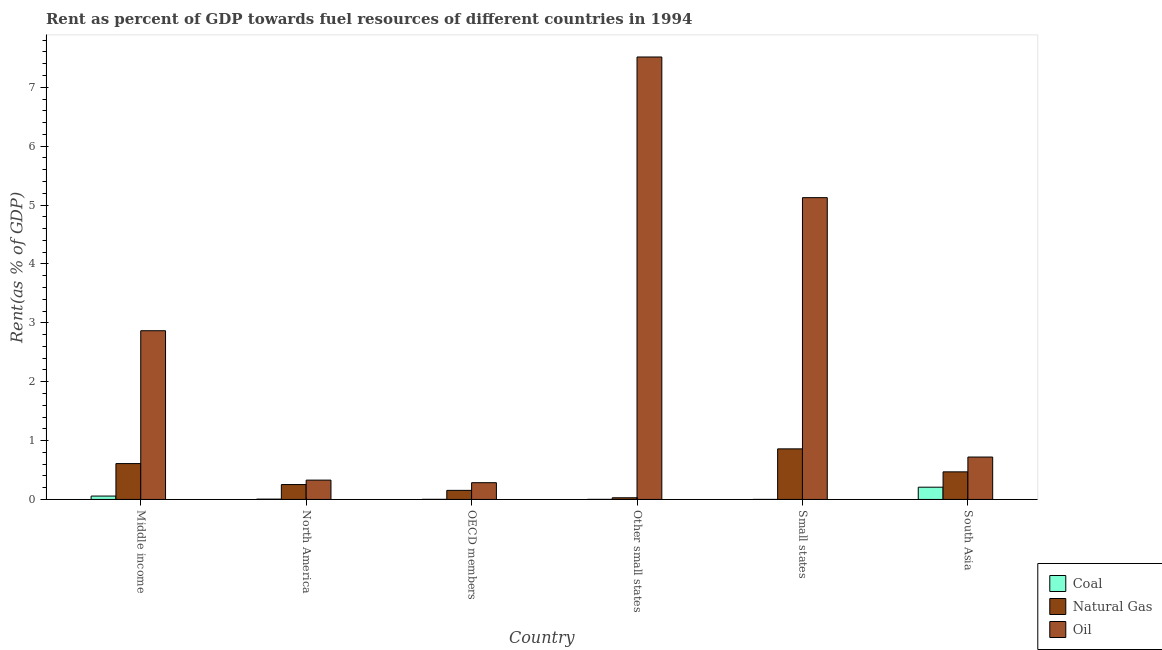How many different coloured bars are there?
Provide a short and direct response. 3. How many groups of bars are there?
Your answer should be compact. 6. Are the number of bars per tick equal to the number of legend labels?
Your response must be concise. Yes. How many bars are there on the 2nd tick from the left?
Your response must be concise. 3. What is the label of the 3rd group of bars from the left?
Provide a short and direct response. OECD members. What is the rent towards coal in Small states?
Keep it short and to the point. 0. Across all countries, what is the maximum rent towards oil?
Your answer should be very brief. 7.51. Across all countries, what is the minimum rent towards natural gas?
Provide a succinct answer. 0.03. In which country was the rent towards coal minimum?
Provide a succinct answer. Small states. What is the total rent towards natural gas in the graph?
Your response must be concise. 2.37. What is the difference between the rent towards coal in Small states and that in South Asia?
Provide a succinct answer. -0.21. What is the difference between the rent towards coal in North America and the rent towards natural gas in Other small states?
Your response must be concise. -0.02. What is the average rent towards natural gas per country?
Ensure brevity in your answer.  0.4. What is the difference between the rent towards natural gas and rent towards coal in OECD members?
Offer a very short reply. 0.15. What is the ratio of the rent towards natural gas in Middle income to that in North America?
Your answer should be very brief. 2.41. Is the rent towards natural gas in Middle income less than that in North America?
Offer a terse response. No. Is the difference between the rent towards oil in Middle income and North America greater than the difference between the rent towards coal in Middle income and North America?
Your answer should be compact. Yes. What is the difference between the highest and the second highest rent towards coal?
Your answer should be very brief. 0.15. What is the difference between the highest and the lowest rent towards natural gas?
Your answer should be compact. 0.83. What does the 3rd bar from the left in Other small states represents?
Offer a very short reply. Oil. What does the 2nd bar from the right in Middle income represents?
Make the answer very short. Natural Gas. How many bars are there?
Keep it short and to the point. 18. Are all the bars in the graph horizontal?
Provide a short and direct response. No. What is the difference between two consecutive major ticks on the Y-axis?
Your response must be concise. 1. Does the graph contain any zero values?
Ensure brevity in your answer.  No. Where does the legend appear in the graph?
Offer a terse response. Bottom right. How many legend labels are there?
Ensure brevity in your answer.  3. What is the title of the graph?
Your response must be concise. Rent as percent of GDP towards fuel resources of different countries in 1994. What is the label or title of the X-axis?
Provide a succinct answer. Country. What is the label or title of the Y-axis?
Provide a short and direct response. Rent(as % of GDP). What is the Rent(as % of GDP) in Coal in Middle income?
Your response must be concise. 0.06. What is the Rent(as % of GDP) in Natural Gas in Middle income?
Your answer should be compact. 0.61. What is the Rent(as % of GDP) of Oil in Middle income?
Keep it short and to the point. 2.87. What is the Rent(as % of GDP) in Coal in North America?
Make the answer very short. 0.01. What is the Rent(as % of GDP) in Natural Gas in North America?
Make the answer very short. 0.25. What is the Rent(as % of GDP) of Oil in North America?
Make the answer very short. 0.33. What is the Rent(as % of GDP) of Coal in OECD members?
Give a very brief answer. 0. What is the Rent(as % of GDP) in Natural Gas in OECD members?
Keep it short and to the point. 0.15. What is the Rent(as % of GDP) in Oil in OECD members?
Provide a succinct answer. 0.28. What is the Rent(as % of GDP) of Coal in Other small states?
Your response must be concise. 0. What is the Rent(as % of GDP) in Natural Gas in Other small states?
Keep it short and to the point. 0.03. What is the Rent(as % of GDP) in Oil in Other small states?
Your response must be concise. 7.51. What is the Rent(as % of GDP) in Coal in Small states?
Your answer should be compact. 0. What is the Rent(as % of GDP) of Natural Gas in Small states?
Make the answer very short. 0.86. What is the Rent(as % of GDP) of Oil in Small states?
Ensure brevity in your answer.  5.13. What is the Rent(as % of GDP) in Coal in South Asia?
Provide a succinct answer. 0.21. What is the Rent(as % of GDP) in Natural Gas in South Asia?
Make the answer very short. 0.47. What is the Rent(as % of GDP) in Oil in South Asia?
Ensure brevity in your answer.  0.72. Across all countries, what is the maximum Rent(as % of GDP) of Coal?
Keep it short and to the point. 0.21. Across all countries, what is the maximum Rent(as % of GDP) in Natural Gas?
Provide a short and direct response. 0.86. Across all countries, what is the maximum Rent(as % of GDP) in Oil?
Keep it short and to the point. 7.51. Across all countries, what is the minimum Rent(as % of GDP) of Coal?
Your answer should be compact. 0. Across all countries, what is the minimum Rent(as % of GDP) in Natural Gas?
Your answer should be compact. 0.03. Across all countries, what is the minimum Rent(as % of GDP) in Oil?
Offer a very short reply. 0.28. What is the total Rent(as % of GDP) of Coal in the graph?
Offer a very short reply. 0.27. What is the total Rent(as % of GDP) of Natural Gas in the graph?
Your answer should be compact. 2.37. What is the total Rent(as % of GDP) in Oil in the graph?
Give a very brief answer. 16.84. What is the difference between the Rent(as % of GDP) of Coal in Middle income and that in North America?
Your response must be concise. 0.05. What is the difference between the Rent(as % of GDP) in Natural Gas in Middle income and that in North America?
Ensure brevity in your answer.  0.36. What is the difference between the Rent(as % of GDP) in Oil in Middle income and that in North America?
Offer a terse response. 2.54. What is the difference between the Rent(as % of GDP) of Coal in Middle income and that in OECD members?
Keep it short and to the point. 0.06. What is the difference between the Rent(as % of GDP) of Natural Gas in Middle income and that in OECD members?
Your answer should be very brief. 0.45. What is the difference between the Rent(as % of GDP) in Oil in Middle income and that in OECD members?
Your response must be concise. 2.58. What is the difference between the Rent(as % of GDP) of Coal in Middle income and that in Other small states?
Ensure brevity in your answer.  0.06. What is the difference between the Rent(as % of GDP) in Natural Gas in Middle income and that in Other small states?
Keep it short and to the point. 0.58. What is the difference between the Rent(as % of GDP) in Oil in Middle income and that in Other small states?
Keep it short and to the point. -4.65. What is the difference between the Rent(as % of GDP) in Coal in Middle income and that in Small states?
Provide a succinct answer. 0.06. What is the difference between the Rent(as % of GDP) in Natural Gas in Middle income and that in Small states?
Make the answer very short. -0.25. What is the difference between the Rent(as % of GDP) in Oil in Middle income and that in Small states?
Keep it short and to the point. -2.26. What is the difference between the Rent(as % of GDP) in Coal in Middle income and that in South Asia?
Make the answer very short. -0.15. What is the difference between the Rent(as % of GDP) in Natural Gas in Middle income and that in South Asia?
Offer a terse response. 0.14. What is the difference between the Rent(as % of GDP) of Oil in Middle income and that in South Asia?
Make the answer very short. 2.15. What is the difference between the Rent(as % of GDP) of Coal in North America and that in OECD members?
Your response must be concise. 0. What is the difference between the Rent(as % of GDP) in Natural Gas in North America and that in OECD members?
Keep it short and to the point. 0.1. What is the difference between the Rent(as % of GDP) in Oil in North America and that in OECD members?
Keep it short and to the point. 0.04. What is the difference between the Rent(as % of GDP) of Coal in North America and that in Other small states?
Provide a succinct answer. 0. What is the difference between the Rent(as % of GDP) in Natural Gas in North America and that in Other small states?
Ensure brevity in your answer.  0.22. What is the difference between the Rent(as % of GDP) of Oil in North America and that in Other small states?
Make the answer very short. -7.19. What is the difference between the Rent(as % of GDP) in Coal in North America and that in Small states?
Give a very brief answer. 0. What is the difference between the Rent(as % of GDP) of Natural Gas in North America and that in Small states?
Offer a very short reply. -0.61. What is the difference between the Rent(as % of GDP) in Oil in North America and that in Small states?
Your answer should be compact. -4.8. What is the difference between the Rent(as % of GDP) of Coal in North America and that in South Asia?
Offer a very short reply. -0.2. What is the difference between the Rent(as % of GDP) of Natural Gas in North America and that in South Asia?
Ensure brevity in your answer.  -0.22. What is the difference between the Rent(as % of GDP) in Oil in North America and that in South Asia?
Your response must be concise. -0.39. What is the difference between the Rent(as % of GDP) in Coal in OECD members and that in Other small states?
Offer a terse response. 0. What is the difference between the Rent(as % of GDP) in Natural Gas in OECD members and that in Other small states?
Keep it short and to the point. 0.13. What is the difference between the Rent(as % of GDP) in Oil in OECD members and that in Other small states?
Provide a succinct answer. -7.23. What is the difference between the Rent(as % of GDP) of Coal in OECD members and that in Small states?
Provide a succinct answer. 0. What is the difference between the Rent(as % of GDP) of Natural Gas in OECD members and that in Small states?
Your answer should be very brief. -0.7. What is the difference between the Rent(as % of GDP) in Oil in OECD members and that in Small states?
Your answer should be very brief. -4.84. What is the difference between the Rent(as % of GDP) of Coal in OECD members and that in South Asia?
Give a very brief answer. -0.21. What is the difference between the Rent(as % of GDP) in Natural Gas in OECD members and that in South Asia?
Offer a terse response. -0.31. What is the difference between the Rent(as % of GDP) in Oil in OECD members and that in South Asia?
Offer a terse response. -0.44. What is the difference between the Rent(as % of GDP) of Coal in Other small states and that in Small states?
Provide a short and direct response. 0. What is the difference between the Rent(as % of GDP) of Natural Gas in Other small states and that in Small states?
Offer a terse response. -0.83. What is the difference between the Rent(as % of GDP) of Oil in Other small states and that in Small states?
Your response must be concise. 2.39. What is the difference between the Rent(as % of GDP) of Coal in Other small states and that in South Asia?
Your answer should be compact. -0.21. What is the difference between the Rent(as % of GDP) in Natural Gas in Other small states and that in South Asia?
Give a very brief answer. -0.44. What is the difference between the Rent(as % of GDP) in Oil in Other small states and that in South Asia?
Give a very brief answer. 6.79. What is the difference between the Rent(as % of GDP) of Coal in Small states and that in South Asia?
Keep it short and to the point. -0.21. What is the difference between the Rent(as % of GDP) of Natural Gas in Small states and that in South Asia?
Your response must be concise. 0.39. What is the difference between the Rent(as % of GDP) in Oil in Small states and that in South Asia?
Your answer should be compact. 4.41. What is the difference between the Rent(as % of GDP) of Coal in Middle income and the Rent(as % of GDP) of Natural Gas in North America?
Provide a succinct answer. -0.2. What is the difference between the Rent(as % of GDP) of Coal in Middle income and the Rent(as % of GDP) of Oil in North America?
Offer a terse response. -0.27. What is the difference between the Rent(as % of GDP) in Natural Gas in Middle income and the Rent(as % of GDP) in Oil in North America?
Your answer should be compact. 0.28. What is the difference between the Rent(as % of GDP) of Coal in Middle income and the Rent(as % of GDP) of Natural Gas in OECD members?
Your response must be concise. -0.1. What is the difference between the Rent(as % of GDP) of Coal in Middle income and the Rent(as % of GDP) of Oil in OECD members?
Your answer should be very brief. -0.23. What is the difference between the Rent(as % of GDP) in Natural Gas in Middle income and the Rent(as % of GDP) in Oil in OECD members?
Offer a very short reply. 0.32. What is the difference between the Rent(as % of GDP) of Coal in Middle income and the Rent(as % of GDP) of Natural Gas in Other small states?
Your response must be concise. 0.03. What is the difference between the Rent(as % of GDP) in Coal in Middle income and the Rent(as % of GDP) in Oil in Other small states?
Give a very brief answer. -7.46. What is the difference between the Rent(as % of GDP) of Natural Gas in Middle income and the Rent(as % of GDP) of Oil in Other small states?
Give a very brief answer. -6.91. What is the difference between the Rent(as % of GDP) of Coal in Middle income and the Rent(as % of GDP) of Natural Gas in Small states?
Your answer should be compact. -0.8. What is the difference between the Rent(as % of GDP) in Coal in Middle income and the Rent(as % of GDP) in Oil in Small states?
Your answer should be very brief. -5.07. What is the difference between the Rent(as % of GDP) of Natural Gas in Middle income and the Rent(as % of GDP) of Oil in Small states?
Keep it short and to the point. -4.52. What is the difference between the Rent(as % of GDP) of Coal in Middle income and the Rent(as % of GDP) of Natural Gas in South Asia?
Give a very brief answer. -0.41. What is the difference between the Rent(as % of GDP) in Coal in Middle income and the Rent(as % of GDP) in Oil in South Asia?
Provide a succinct answer. -0.66. What is the difference between the Rent(as % of GDP) of Natural Gas in Middle income and the Rent(as % of GDP) of Oil in South Asia?
Your response must be concise. -0.11. What is the difference between the Rent(as % of GDP) of Coal in North America and the Rent(as % of GDP) of Natural Gas in OECD members?
Offer a very short reply. -0.15. What is the difference between the Rent(as % of GDP) in Coal in North America and the Rent(as % of GDP) in Oil in OECD members?
Offer a terse response. -0.28. What is the difference between the Rent(as % of GDP) in Natural Gas in North America and the Rent(as % of GDP) in Oil in OECD members?
Your answer should be compact. -0.03. What is the difference between the Rent(as % of GDP) of Coal in North America and the Rent(as % of GDP) of Natural Gas in Other small states?
Your answer should be very brief. -0.02. What is the difference between the Rent(as % of GDP) of Coal in North America and the Rent(as % of GDP) of Oil in Other small states?
Keep it short and to the point. -7.51. What is the difference between the Rent(as % of GDP) in Natural Gas in North America and the Rent(as % of GDP) in Oil in Other small states?
Keep it short and to the point. -7.26. What is the difference between the Rent(as % of GDP) of Coal in North America and the Rent(as % of GDP) of Natural Gas in Small states?
Ensure brevity in your answer.  -0.85. What is the difference between the Rent(as % of GDP) in Coal in North America and the Rent(as % of GDP) in Oil in Small states?
Your response must be concise. -5.12. What is the difference between the Rent(as % of GDP) of Natural Gas in North America and the Rent(as % of GDP) of Oil in Small states?
Offer a terse response. -4.87. What is the difference between the Rent(as % of GDP) in Coal in North America and the Rent(as % of GDP) in Natural Gas in South Asia?
Provide a short and direct response. -0.46. What is the difference between the Rent(as % of GDP) of Coal in North America and the Rent(as % of GDP) of Oil in South Asia?
Ensure brevity in your answer.  -0.71. What is the difference between the Rent(as % of GDP) in Natural Gas in North America and the Rent(as % of GDP) in Oil in South Asia?
Keep it short and to the point. -0.47. What is the difference between the Rent(as % of GDP) of Coal in OECD members and the Rent(as % of GDP) of Natural Gas in Other small states?
Your response must be concise. -0.03. What is the difference between the Rent(as % of GDP) of Coal in OECD members and the Rent(as % of GDP) of Oil in Other small states?
Ensure brevity in your answer.  -7.51. What is the difference between the Rent(as % of GDP) in Natural Gas in OECD members and the Rent(as % of GDP) in Oil in Other small states?
Your response must be concise. -7.36. What is the difference between the Rent(as % of GDP) in Coal in OECD members and the Rent(as % of GDP) in Natural Gas in Small states?
Your answer should be very brief. -0.86. What is the difference between the Rent(as % of GDP) in Coal in OECD members and the Rent(as % of GDP) in Oil in Small states?
Your answer should be compact. -5.12. What is the difference between the Rent(as % of GDP) in Natural Gas in OECD members and the Rent(as % of GDP) in Oil in Small states?
Keep it short and to the point. -4.97. What is the difference between the Rent(as % of GDP) in Coal in OECD members and the Rent(as % of GDP) in Natural Gas in South Asia?
Your answer should be compact. -0.47. What is the difference between the Rent(as % of GDP) in Coal in OECD members and the Rent(as % of GDP) in Oil in South Asia?
Offer a terse response. -0.72. What is the difference between the Rent(as % of GDP) in Natural Gas in OECD members and the Rent(as % of GDP) in Oil in South Asia?
Ensure brevity in your answer.  -0.57. What is the difference between the Rent(as % of GDP) in Coal in Other small states and the Rent(as % of GDP) in Natural Gas in Small states?
Your response must be concise. -0.86. What is the difference between the Rent(as % of GDP) in Coal in Other small states and the Rent(as % of GDP) in Oil in Small states?
Your answer should be compact. -5.12. What is the difference between the Rent(as % of GDP) of Natural Gas in Other small states and the Rent(as % of GDP) of Oil in Small states?
Make the answer very short. -5.1. What is the difference between the Rent(as % of GDP) in Coal in Other small states and the Rent(as % of GDP) in Natural Gas in South Asia?
Give a very brief answer. -0.47. What is the difference between the Rent(as % of GDP) of Coal in Other small states and the Rent(as % of GDP) of Oil in South Asia?
Provide a succinct answer. -0.72. What is the difference between the Rent(as % of GDP) of Natural Gas in Other small states and the Rent(as % of GDP) of Oil in South Asia?
Ensure brevity in your answer.  -0.69. What is the difference between the Rent(as % of GDP) of Coal in Small states and the Rent(as % of GDP) of Natural Gas in South Asia?
Offer a very short reply. -0.47. What is the difference between the Rent(as % of GDP) in Coal in Small states and the Rent(as % of GDP) in Oil in South Asia?
Make the answer very short. -0.72. What is the difference between the Rent(as % of GDP) of Natural Gas in Small states and the Rent(as % of GDP) of Oil in South Asia?
Your answer should be compact. 0.14. What is the average Rent(as % of GDP) in Coal per country?
Provide a short and direct response. 0.05. What is the average Rent(as % of GDP) of Natural Gas per country?
Give a very brief answer. 0.4. What is the average Rent(as % of GDP) of Oil per country?
Your answer should be very brief. 2.81. What is the difference between the Rent(as % of GDP) in Coal and Rent(as % of GDP) in Natural Gas in Middle income?
Provide a short and direct response. -0.55. What is the difference between the Rent(as % of GDP) in Coal and Rent(as % of GDP) in Oil in Middle income?
Provide a succinct answer. -2.81. What is the difference between the Rent(as % of GDP) in Natural Gas and Rent(as % of GDP) in Oil in Middle income?
Your answer should be very brief. -2.26. What is the difference between the Rent(as % of GDP) of Coal and Rent(as % of GDP) of Natural Gas in North America?
Make the answer very short. -0.25. What is the difference between the Rent(as % of GDP) of Coal and Rent(as % of GDP) of Oil in North America?
Provide a succinct answer. -0.32. What is the difference between the Rent(as % of GDP) of Natural Gas and Rent(as % of GDP) of Oil in North America?
Your answer should be compact. -0.08. What is the difference between the Rent(as % of GDP) of Coal and Rent(as % of GDP) of Natural Gas in OECD members?
Provide a short and direct response. -0.15. What is the difference between the Rent(as % of GDP) of Coal and Rent(as % of GDP) of Oil in OECD members?
Your answer should be very brief. -0.28. What is the difference between the Rent(as % of GDP) of Natural Gas and Rent(as % of GDP) of Oil in OECD members?
Your response must be concise. -0.13. What is the difference between the Rent(as % of GDP) in Coal and Rent(as % of GDP) in Natural Gas in Other small states?
Ensure brevity in your answer.  -0.03. What is the difference between the Rent(as % of GDP) of Coal and Rent(as % of GDP) of Oil in Other small states?
Provide a succinct answer. -7.51. What is the difference between the Rent(as % of GDP) of Natural Gas and Rent(as % of GDP) of Oil in Other small states?
Keep it short and to the point. -7.49. What is the difference between the Rent(as % of GDP) of Coal and Rent(as % of GDP) of Natural Gas in Small states?
Offer a very short reply. -0.86. What is the difference between the Rent(as % of GDP) of Coal and Rent(as % of GDP) of Oil in Small states?
Your response must be concise. -5.12. What is the difference between the Rent(as % of GDP) of Natural Gas and Rent(as % of GDP) of Oil in Small states?
Provide a succinct answer. -4.27. What is the difference between the Rent(as % of GDP) of Coal and Rent(as % of GDP) of Natural Gas in South Asia?
Provide a short and direct response. -0.26. What is the difference between the Rent(as % of GDP) in Coal and Rent(as % of GDP) in Oil in South Asia?
Make the answer very short. -0.51. What is the difference between the Rent(as % of GDP) in Natural Gas and Rent(as % of GDP) in Oil in South Asia?
Provide a short and direct response. -0.25. What is the ratio of the Rent(as % of GDP) of Coal in Middle income to that in North America?
Ensure brevity in your answer.  10.65. What is the ratio of the Rent(as % of GDP) in Natural Gas in Middle income to that in North America?
Your answer should be compact. 2.41. What is the ratio of the Rent(as % of GDP) in Oil in Middle income to that in North America?
Your answer should be compact. 8.72. What is the ratio of the Rent(as % of GDP) in Coal in Middle income to that in OECD members?
Ensure brevity in your answer.  29.05. What is the ratio of the Rent(as % of GDP) of Natural Gas in Middle income to that in OECD members?
Make the answer very short. 3.95. What is the ratio of the Rent(as % of GDP) in Oil in Middle income to that in OECD members?
Keep it short and to the point. 10.07. What is the ratio of the Rent(as % of GDP) of Coal in Middle income to that in Other small states?
Your answer should be very brief. 43.1. What is the ratio of the Rent(as % of GDP) of Natural Gas in Middle income to that in Other small states?
Your answer should be very brief. 21.4. What is the ratio of the Rent(as % of GDP) of Oil in Middle income to that in Other small states?
Your response must be concise. 0.38. What is the ratio of the Rent(as % of GDP) in Coal in Middle income to that in Small states?
Your answer should be compact. 88.94. What is the ratio of the Rent(as % of GDP) of Natural Gas in Middle income to that in Small states?
Make the answer very short. 0.71. What is the ratio of the Rent(as % of GDP) of Oil in Middle income to that in Small states?
Provide a succinct answer. 0.56. What is the ratio of the Rent(as % of GDP) in Coal in Middle income to that in South Asia?
Keep it short and to the point. 0.28. What is the ratio of the Rent(as % of GDP) of Natural Gas in Middle income to that in South Asia?
Your answer should be very brief. 1.3. What is the ratio of the Rent(as % of GDP) in Oil in Middle income to that in South Asia?
Your answer should be compact. 3.98. What is the ratio of the Rent(as % of GDP) of Coal in North America to that in OECD members?
Your answer should be compact. 2.73. What is the ratio of the Rent(as % of GDP) of Natural Gas in North America to that in OECD members?
Ensure brevity in your answer.  1.64. What is the ratio of the Rent(as % of GDP) of Oil in North America to that in OECD members?
Your answer should be very brief. 1.15. What is the ratio of the Rent(as % of GDP) in Coal in North America to that in Other small states?
Make the answer very short. 4.05. What is the ratio of the Rent(as % of GDP) in Natural Gas in North America to that in Other small states?
Ensure brevity in your answer.  8.89. What is the ratio of the Rent(as % of GDP) of Oil in North America to that in Other small states?
Keep it short and to the point. 0.04. What is the ratio of the Rent(as % of GDP) of Coal in North America to that in Small states?
Provide a short and direct response. 8.35. What is the ratio of the Rent(as % of GDP) in Natural Gas in North America to that in Small states?
Give a very brief answer. 0.29. What is the ratio of the Rent(as % of GDP) in Oil in North America to that in Small states?
Keep it short and to the point. 0.06. What is the ratio of the Rent(as % of GDP) in Coal in North America to that in South Asia?
Keep it short and to the point. 0.03. What is the ratio of the Rent(as % of GDP) of Natural Gas in North America to that in South Asia?
Provide a succinct answer. 0.54. What is the ratio of the Rent(as % of GDP) of Oil in North America to that in South Asia?
Ensure brevity in your answer.  0.46. What is the ratio of the Rent(as % of GDP) in Coal in OECD members to that in Other small states?
Make the answer very short. 1.48. What is the ratio of the Rent(as % of GDP) in Natural Gas in OECD members to that in Other small states?
Offer a very short reply. 5.42. What is the ratio of the Rent(as % of GDP) in Oil in OECD members to that in Other small states?
Provide a short and direct response. 0.04. What is the ratio of the Rent(as % of GDP) of Coal in OECD members to that in Small states?
Offer a very short reply. 3.06. What is the ratio of the Rent(as % of GDP) in Natural Gas in OECD members to that in Small states?
Offer a very short reply. 0.18. What is the ratio of the Rent(as % of GDP) in Oil in OECD members to that in Small states?
Make the answer very short. 0.06. What is the ratio of the Rent(as % of GDP) in Coal in OECD members to that in South Asia?
Your response must be concise. 0.01. What is the ratio of the Rent(as % of GDP) of Natural Gas in OECD members to that in South Asia?
Offer a terse response. 0.33. What is the ratio of the Rent(as % of GDP) of Oil in OECD members to that in South Asia?
Ensure brevity in your answer.  0.4. What is the ratio of the Rent(as % of GDP) in Coal in Other small states to that in Small states?
Keep it short and to the point. 2.06. What is the ratio of the Rent(as % of GDP) of Natural Gas in Other small states to that in Small states?
Your answer should be very brief. 0.03. What is the ratio of the Rent(as % of GDP) of Oil in Other small states to that in Small states?
Give a very brief answer. 1.47. What is the ratio of the Rent(as % of GDP) of Coal in Other small states to that in South Asia?
Your answer should be compact. 0.01. What is the ratio of the Rent(as % of GDP) in Natural Gas in Other small states to that in South Asia?
Offer a very short reply. 0.06. What is the ratio of the Rent(as % of GDP) of Oil in Other small states to that in South Asia?
Keep it short and to the point. 10.43. What is the ratio of the Rent(as % of GDP) of Coal in Small states to that in South Asia?
Your answer should be very brief. 0. What is the ratio of the Rent(as % of GDP) of Natural Gas in Small states to that in South Asia?
Your answer should be very brief. 1.83. What is the ratio of the Rent(as % of GDP) in Oil in Small states to that in South Asia?
Provide a short and direct response. 7.11. What is the difference between the highest and the second highest Rent(as % of GDP) of Coal?
Your answer should be very brief. 0.15. What is the difference between the highest and the second highest Rent(as % of GDP) in Natural Gas?
Offer a terse response. 0.25. What is the difference between the highest and the second highest Rent(as % of GDP) of Oil?
Provide a short and direct response. 2.39. What is the difference between the highest and the lowest Rent(as % of GDP) in Coal?
Provide a succinct answer. 0.21. What is the difference between the highest and the lowest Rent(as % of GDP) of Natural Gas?
Make the answer very short. 0.83. What is the difference between the highest and the lowest Rent(as % of GDP) of Oil?
Provide a succinct answer. 7.23. 